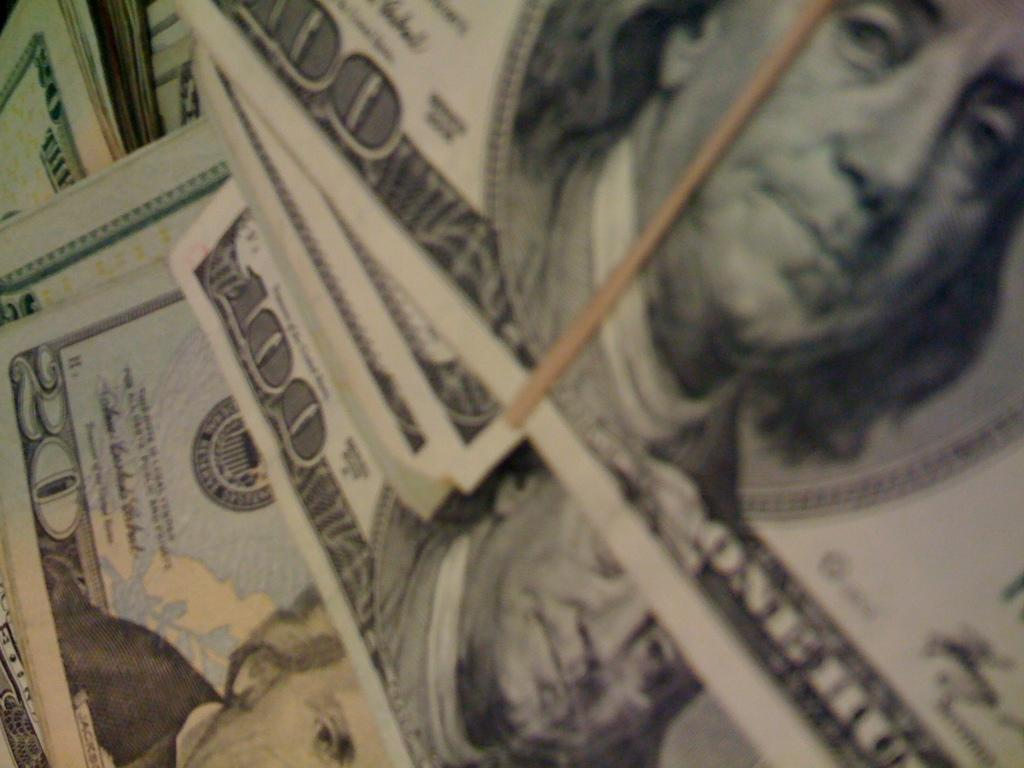What type of items can be seen in the image? There are currency notes in the image. Can you describe the appearance of the currency notes? The currency notes appear to be paper-based and have distinct designs and denominations. What might be the purpose of having currency notes in the image? The presence of currency notes in the image could suggest a financial transaction, savings, or an illustration of value. What type of machine is being offered in the class depicted in the image? There is no machine or class present in the image; it only contains currency notes. 